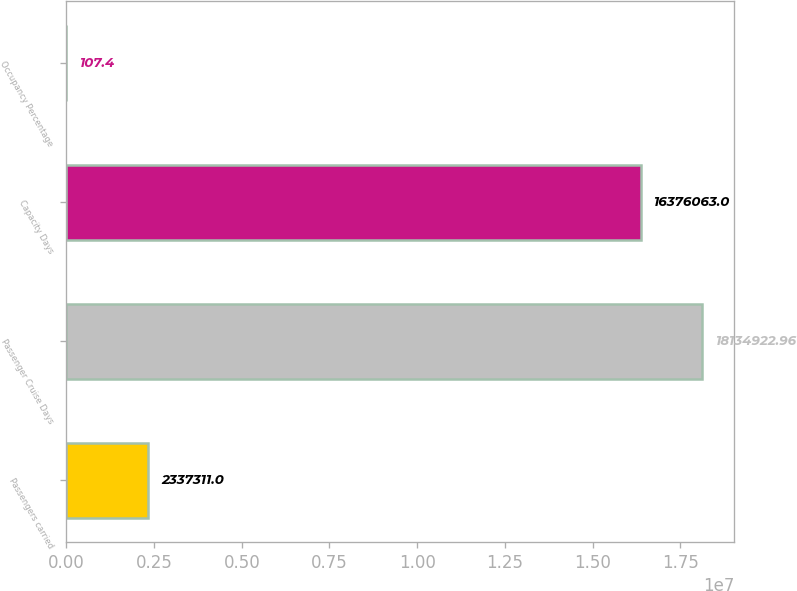Convert chart to OTSL. <chart><loc_0><loc_0><loc_500><loc_500><bar_chart><fcel>Passengers carried<fcel>Passenger Cruise Days<fcel>Capacity Days<fcel>Occupancy Percentage<nl><fcel>2.33731e+06<fcel>1.81349e+07<fcel>1.63761e+07<fcel>107.4<nl></chart> 